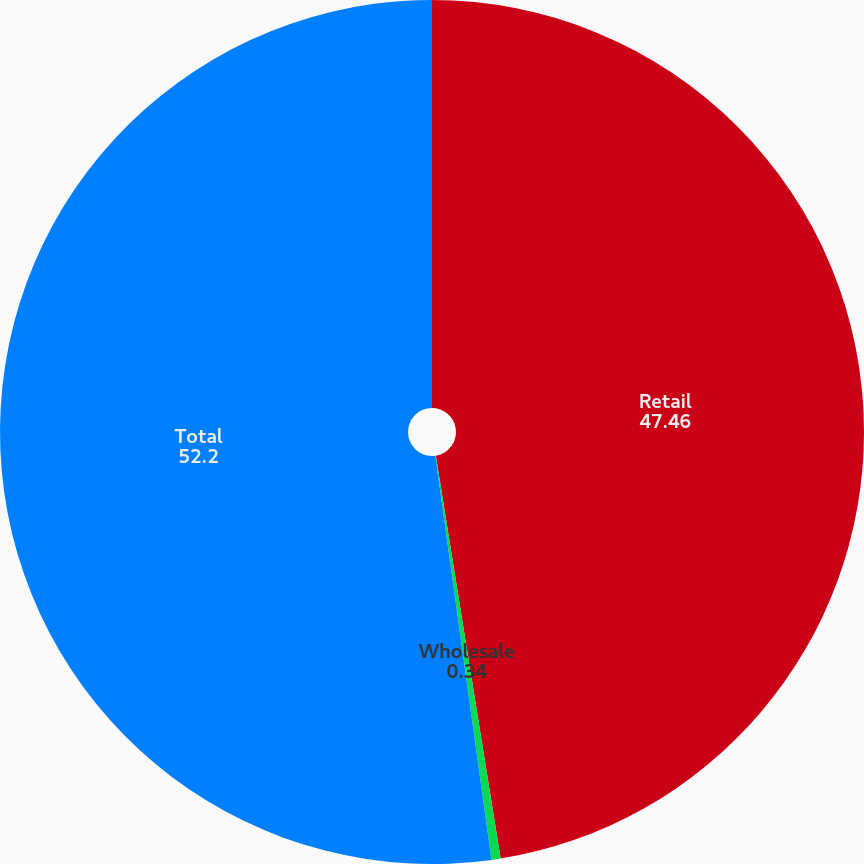Convert chart to OTSL. <chart><loc_0><loc_0><loc_500><loc_500><pie_chart><fcel>Retail<fcel>Wholesale<fcel>Total<nl><fcel>47.46%<fcel>0.34%<fcel>52.2%<nl></chart> 